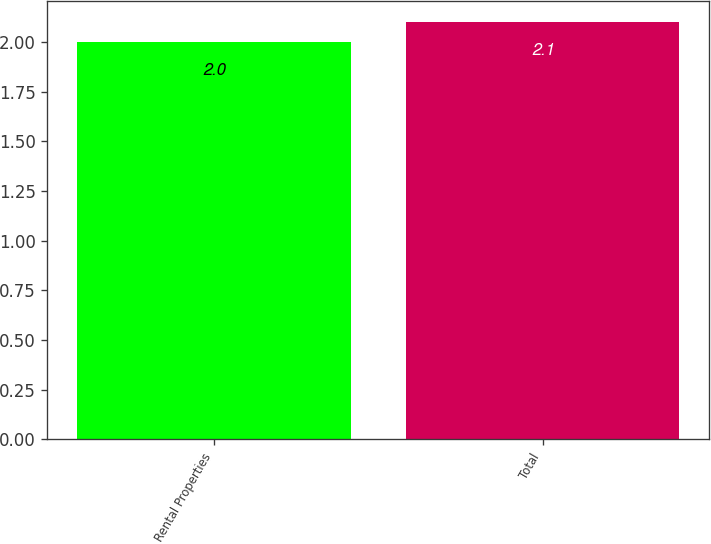<chart> <loc_0><loc_0><loc_500><loc_500><bar_chart><fcel>Rental Properties<fcel>Total<nl><fcel>2<fcel>2.1<nl></chart> 